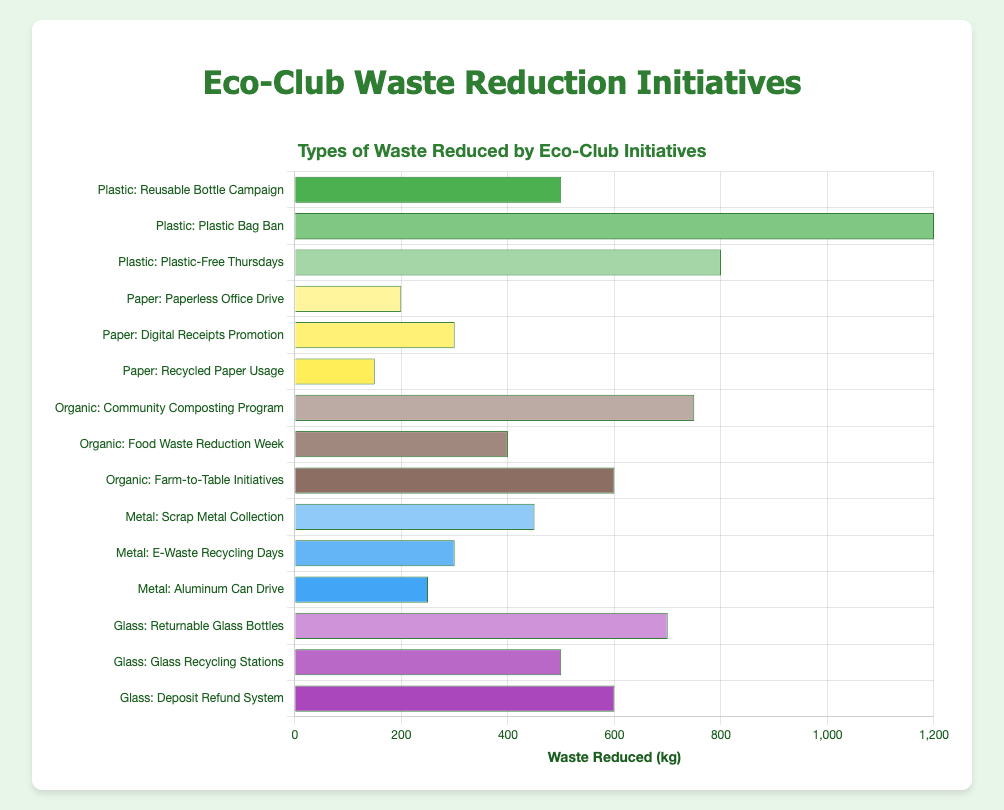What is the total amount of plastic waste reduced by all initiatives? To find the total plastic waste reduced, sum the waste reduced by each plastic initiative: 500 kg (Reusable Bottle Campaign) + 1200 kg (Plastic Bag Ban) + 800 kg (Plastic-Free Thursdays) = 2500 kg.
Answer: 2500 kg Which type of waste has the highest reduction in a single initiative? The highest reduction among all initiatives can be found by comparing the waste reduced values. The Plastic Bag Ban reduces the most with 1200 kg.
Answer: Plastic Which initiative reduced the least amount of waste among all types? Identify the initiative with the smallest value: Recycled Paper Usage reduced 150 kg, which is the lowest among all initiatives.
Answer: Recycled Paper Usage What is the average waste reduction for initiatives targeting organic waste? Sum the organic waste reductions and divide by the number of initiatives: (750 kg + 400 kg + 600 kg) / 3 = 1750 kg / 3 ≈ 583.33 kg.
Answer: 583.33 kg How does the total waste reduction of metal compare to glass waste reduction? Calculate the total waste reduction for metal and glass, then compare: Metal (450 kg + 300 kg + 250 kg = 1000 kg), Glass (700 kg + 500 kg + 600 kg = 1800 kg). Glass has a higher total waste reduction than metal.
Answer: Glass has a higher total Which organic initiative reduced more waste: Community Composting Program or Farm-to-Table Initiatives? Compare the waste reduction values for these two initiatives: Community Composting Program (750 kg) and Farm-to-Table Initiatives (600 kg). The Community Composting Program reduced more waste.
Answer: Community Composting Program What's the combined waste reduction of the Paperless Office Drive and Digital Receipts Promotion? Add the waste reduced by both initiatives: 200 kg (Paperless Office Drive) + 300 kg (Digital Receipts Promotion) = 500 kg.
Answer: 500 kg Which initiative targeting glass waste contributed the second most to waste reduction? Rank the glass initiatives by waste reduction: Returnable Glass Bottles (700 kg), Deposit Refund System (600 kg), Glass Recycling Stations (500 kg). The second highest is the Deposit Refund System.
Answer: Deposit Refund System What is the difference in waste reduction between the Plastic Bag Ban and the Aluminum Can Drive? Subtract the waste reduction of the Aluminum Can Drive from the Plastic Bag Ban: 1200 kg (Plastic Bag Ban) - 250 kg (Aluminum Can Drive) = 950 kg.
Answer: 950 kg 